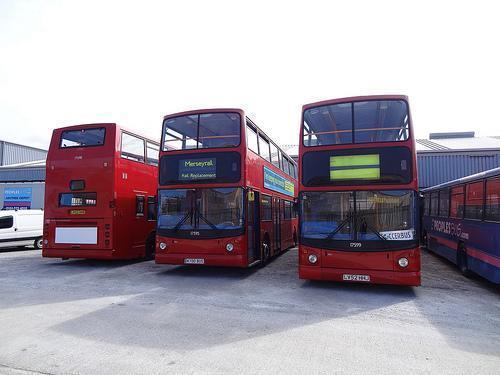How many buses are in the picture?
Give a very brief answer. 4. 